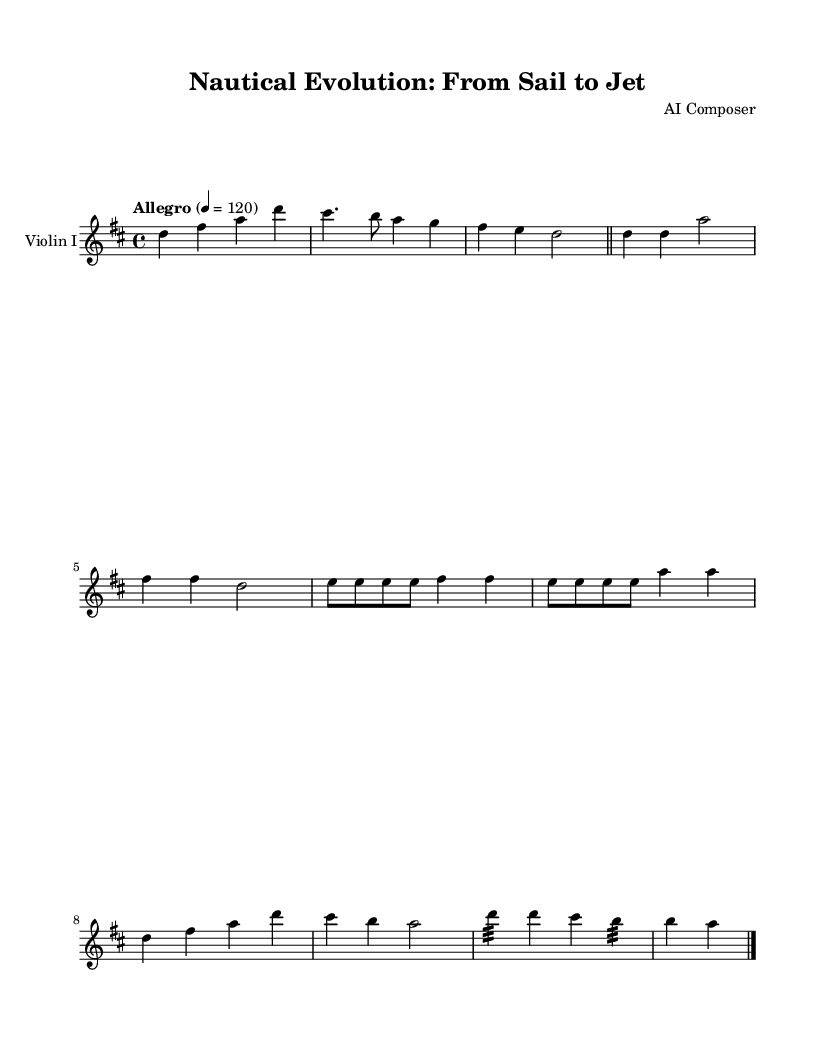What is the key signature of this music? The key signature is D major, which has two sharps: F sharp and C sharp.
Answer: D major What is the time signature of this music? The time signature is 4/4, indicating four beats per measure.
Answer: 4/4 What is the tempo marking for this music? The tempo marking is "Allegro," which indicates a fast and lively pace.
Answer: Allegro How many main themes are present in the composition? There are four main themes: Theme A, Theme B, Theme C, and Theme D, each representing different eras of water transportation.
Answer: Four In which theme is steam power depicted? Steam power is depicted in Theme B, as it introduces the transition from sailing ships to steam-powered boats.
Answer: Theme B What performance technique is used in the Jet Ski Finale? The performance technique used in the Jet Ski Finale is tremolo, noted as repeated fast notes.
Answer: Tremolo Which theme represents modern motorboats? Theme C represents modern motorboats, showcasing the evolution from traditional vessels to contemporary designs.
Answer: Theme C 